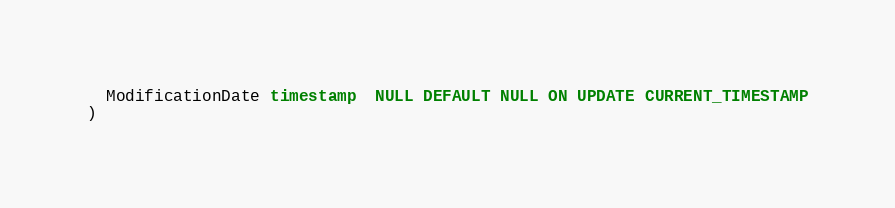Convert code to text. <code><loc_0><loc_0><loc_500><loc_500><_SQL_>  ModificationDate timestamp  NULL DEFAULT NULL ON UPDATE CURRENT_TIMESTAMP
)</code> 